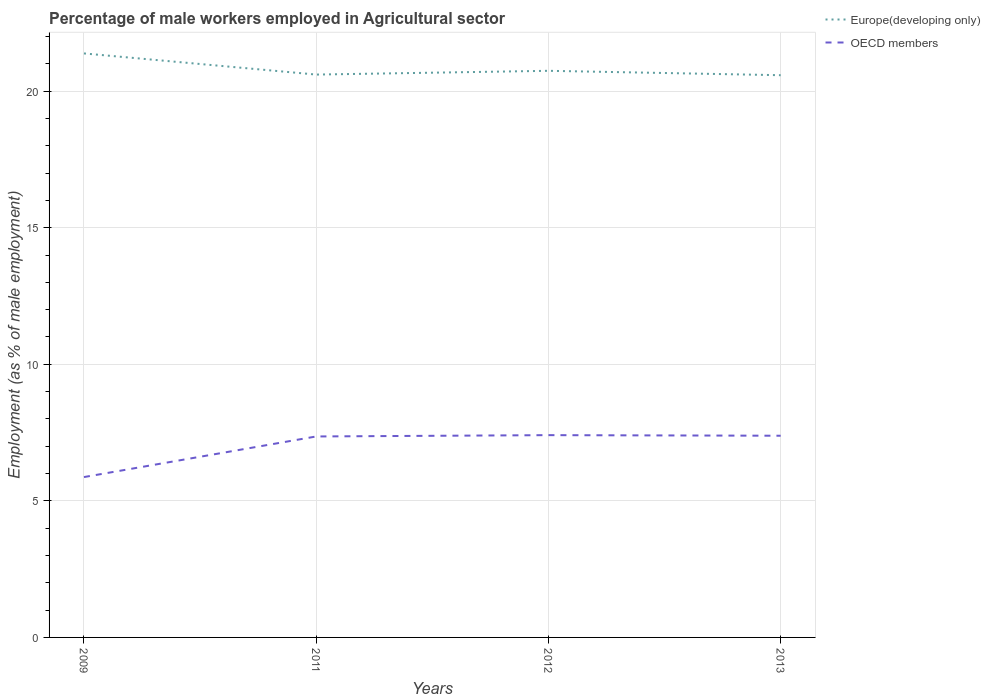Across all years, what is the maximum percentage of male workers employed in Agricultural sector in OECD members?
Give a very brief answer. 5.87. In which year was the percentage of male workers employed in Agricultural sector in OECD members maximum?
Ensure brevity in your answer.  2009. What is the total percentage of male workers employed in Agricultural sector in Europe(developing only) in the graph?
Give a very brief answer. 0.77. What is the difference between the highest and the second highest percentage of male workers employed in Agricultural sector in OECD members?
Give a very brief answer. 1.53. Is the percentage of male workers employed in Agricultural sector in Europe(developing only) strictly greater than the percentage of male workers employed in Agricultural sector in OECD members over the years?
Offer a terse response. No. How many lines are there?
Your answer should be very brief. 2. Are the values on the major ticks of Y-axis written in scientific E-notation?
Your answer should be very brief. No. Does the graph contain grids?
Your answer should be very brief. Yes. How many legend labels are there?
Offer a terse response. 2. How are the legend labels stacked?
Your answer should be very brief. Vertical. What is the title of the graph?
Make the answer very short. Percentage of male workers employed in Agricultural sector. What is the label or title of the Y-axis?
Provide a succinct answer. Employment (as % of male employment). What is the Employment (as % of male employment) in Europe(developing only) in 2009?
Provide a short and direct response. 21.38. What is the Employment (as % of male employment) in OECD members in 2009?
Make the answer very short. 5.87. What is the Employment (as % of male employment) of Europe(developing only) in 2011?
Offer a very short reply. 20.61. What is the Employment (as % of male employment) in OECD members in 2011?
Offer a terse response. 7.36. What is the Employment (as % of male employment) in Europe(developing only) in 2012?
Your answer should be compact. 20.75. What is the Employment (as % of male employment) in OECD members in 2012?
Your answer should be very brief. 7.41. What is the Employment (as % of male employment) of Europe(developing only) in 2013?
Make the answer very short. 20.59. What is the Employment (as % of male employment) of OECD members in 2013?
Offer a terse response. 7.39. Across all years, what is the maximum Employment (as % of male employment) of Europe(developing only)?
Provide a short and direct response. 21.38. Across all years, what is the maximum Employment (as % of male employment) in OECD members?
Your answer should be compact. 7.41. Across all years, what is the minimum Employment (as % of male employment) in Europe(developing only)?
Ensure brevity in your answer.  20.59. Across all years, what is the minimum Employment (as % of male employment) in OECD members?
Your answer should be very brief. 5.87. What is the total Employment (as % of male employment) of Europe(developing only) in the graph?
Your answer should be very brief. 83.32. What is the total Employment (as % of male employment) of OECD members in the graph?
Provide a short and direct response. 28.02. What is the difference between the Employment (as % of male employment) of Europe(developing only) in 2009 and that in 2011?
Offer a terse response. 0.77. What is the difference between the Employment (as % of male employment) in OECD members in 2009 and that in 2011?
Offer a very short reply. -1.49. What is the difference between the Employment (as % of male employment) in Europe(developing only) in 2009 and that in 2012?
Provide a succinct answer. 0.64. What is the difference between the Employment (as % of male employment) in OECD members in 2009 and that in 2012?
Your answer should be compact. -1.53. What is the difference between the Employment (as % of male employment) of Europe(developing only) in 2009 and that in 2013?
Offer a terse response. 0.8. What is the difference between the Employment (as % of male employment) in OECD members in 2009 and that in 2013?
Keep it short and to the point. -1.51. What is the difference between the Employment (as % of male employment) of Europe(developing only) in 2011 and that in 2012?
Keep it short and to the point. -0.14. What is the difference between the Employment (as % of male employment) in OECD members in 2011 and that in 2012?
Your response must be concise. -0.05. What is the difference between the Employment (as % of male employment) in Europe(developing only) in 2011 and that in 2013?
Provide a short and direct response. 0.02. What is the difference between the Employment (as % of male employment) in OECD members in 2011 and that in 2013?
Offer a very short reply. -0.03. What is the difference between the Employment (as % of male employment) of Europe(developing only) in 2012 and that in 2013?
Your response must be concise. 0.16. What is the difference between the Employment (as % of male employment) in OECD members in 2012 and that in 2013?
Your answer should be very brief. 0.02. What is the difference between the Employment (as % of male employment) in Europe(developing only) in 2009 and the Employment (as % of male employment) in OECD members in 2011?
Give a very brief answer. 14.02. What is the difference between the Employment (as % of male employment) of Europe(developing only) in 2009 and the Employment (as % of male employment) of OECD members in 2012?
Make the answer very short. 13.98. What is the difference between the Employment (as % of male employment) of Europe(developing only) in 2009 and the Employment (as % of male employment) of OECD members in 2013?
Offer a very short reply. 14. What is the difference between the Employment (as % of male employment) in Europe(developing only) in 2011 and the Employment (as % of male employment) in OECD members in 2012?
Provide a short and direct response. 13.2. What is the difference between the Employment (as % of male employment) of Europe(developing only) in 2011 and the Employment (as % of male employment) of OECD members in 2013?
Your answer should be compact. 13.22. What is the difference between the Employment (as % of male employment) of Europe(developing only) in 2012 and the Employment (as % of male employment) of OECD members in 2013?
Offer a very short reply. 13.36. What is the average Employment (as % of male employment) of Europe(developing only) per year?
Make the answer very short. 20.83. What is the average Employment (as % of male employment) in OECD members per year?
Make the answer very short. 7.01. In the year 2009, what is the difference between the Employment (as % of male employment) of Europe(developing only) and Employment (as % of male employment) of OECD members?
Make the answer very short. 15.51. In the year 2011, what is the difference between the Employment (as % of male employment) in Europe(developing only) and Employment (as % of male employment) in OECD members?
Offer a very short reply. 13.25. In the year 2012, what is the difference between the Employment (as % of male employment) in Europe(developing only) and Employment (as % of male employment) in OECD members?
Offer a terse response. 13.34. In the year 2013, what is the difference between the Employment (as % of male employment) in Europe(developing only) and Employment (as % of male employment) in OECD members?
Your answer should be very brief. 13.2. What is the ratio of the Employment (as % of male employment) in Europe(developing only) in 2009 to that in 2011?
Provide a succinct answer. 1.04. What is the ratio of the Employment (as % of male employment) of OECD members in 2009 to that in 2011?
Your response must be concise. 0.8. What is the ratio of the Employment (as % of male employment) in Europe(developing only) in 2009 to that in 2012?
Ensure brevity in your answer.  1.03. What is the ratio of the Employment (as % of male employment) of OECD members in 2009 to that in 2012?
Offer a very short reply. 0.79. What is the ratio of the Employment (as % of male employment) in Europe(developing only) in 2009 to that in 2013?
Keep it short and to the point. 1.04. What is the ratio of the Employment (as % of male employment) of OECD members in 2009 to that in 2013?
Offer a very short reply. 0.8. What is the ratio of the Employment (as % of male employment) in OECD members in 2011 to that in 2013?
Offer a very short reply. 1. What is the ratio of the Employment (as % of male employment) in OECD members in 2012 to that in 2013?
Provide a short and direct response. 1. What is the difference between the highest and the second highest Employment (as % of male employment) in Europe(developing only)?
Offer a terse response. 0.64. What is the difference between the highest and the second highest Employment (as % of male employment) in OECD members?
Offer a terse response. 0.02. What is the difference between the highest and the lowest Employment (as % of male employment) in Europe(developing only)?
Ensure brevity in your answer.  0.8. What is the difference between the highest and the lowest Employment (as % of male employment) of OECD members?
Offer a very short reply. 1.53. 